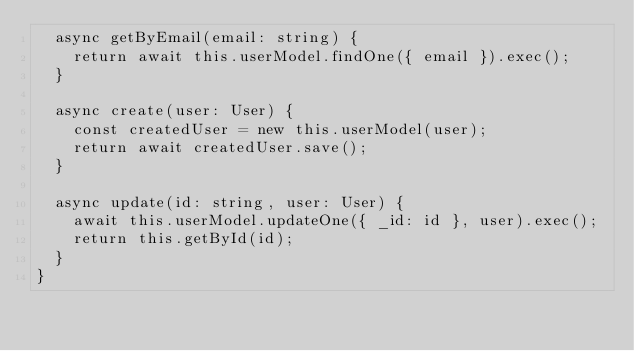Convert code to text. <code><loc_0><loc_0><loc_500><loc_500><_TypeScript_>  async getByEmail(email: string) {
    return await this.userModel.findOne({ email }).exec();
  }

  async create(user: User) {
    const createdUser = new this.userModel(user);
    return await createdUser.save();
  }

  async update(id: string, user: User) {
    await this.userModel.updateOne({ _id: id }, user).exec();
    return this.getById(id);
  }
}
</code> 